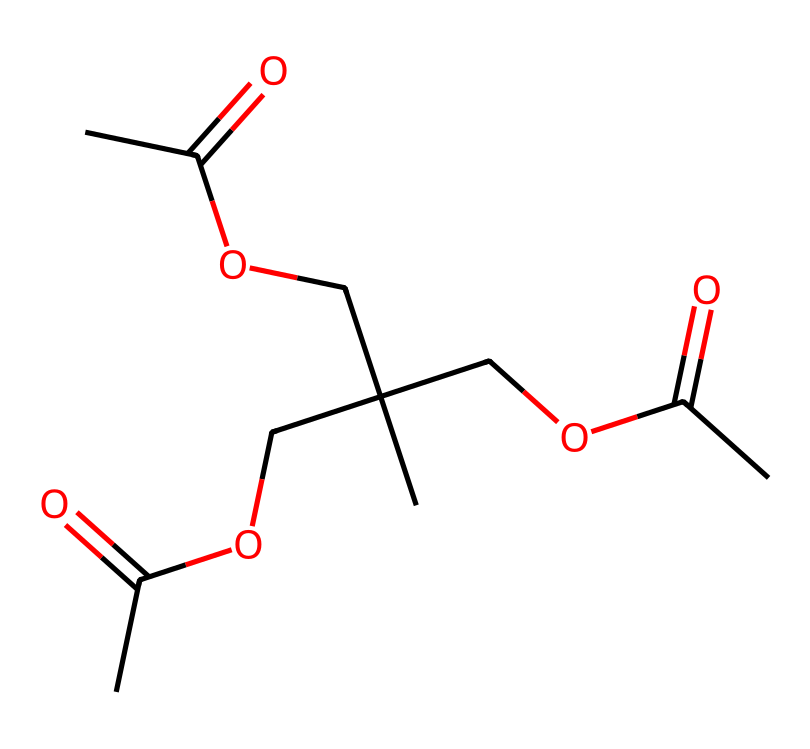What type of polymer is represented by this SMILES? The SMILES representation includes ester functional groups (-COOR) multiple times, indicating that it is a polyester.
Answer: polyester How many ester functional groups are present in this chemical? By examining the SMILES, we can count four occurrences of the ester linkage, which indicates the presence of four ester functional groups.
Answer: four What is the total number of carbon atoms in this polymer? Counting the carbon atoms from the SMILES representation, we find there are 10 carbon atoms present.
Answer: ten What type of bond connects the carbonyl carbon to the oxygen in the ester groups? In each ester group, a carbonyl carbon is connected to an oxygen atom via a double bond, which is characteristic of esters.
Answer: double bond Can this polymer be considered biodegradable? Due to its ester linkages which can undergo hydrolysis in the presence of water, this polyester has potential for biodegradability.
Answer: yes What main property makes this polymer suitable for dance costumes? The flexibility and lightweight nature of polyester fibers make them ideal for garments like dance costumes, allowing for ease of movement.
Answer: flexibility 